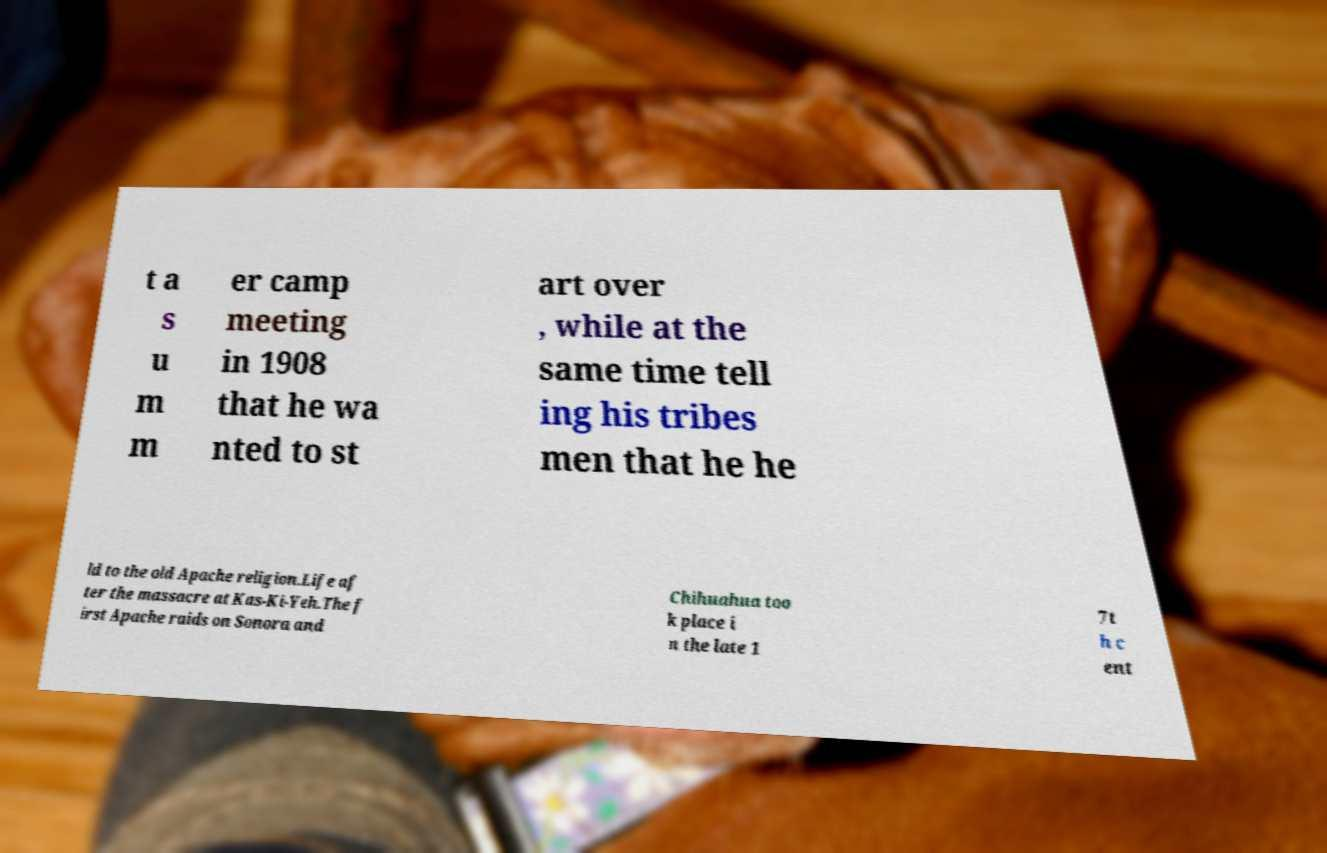Can you read and provide the text displayed in the image?This photo seems to have some interesting text. Can you extract and type it out for me? t a s u m m er camp meeting in 1908 that he wa nted to st art over , while at the same time tell ing his tribes men that he he ld to the old Apache religion.Life af ter the massacre at Kas-Ki-Yeh.The f irst Apache raids on Sonora and Chihuahua too k place i n the late 1 7t h c ent 